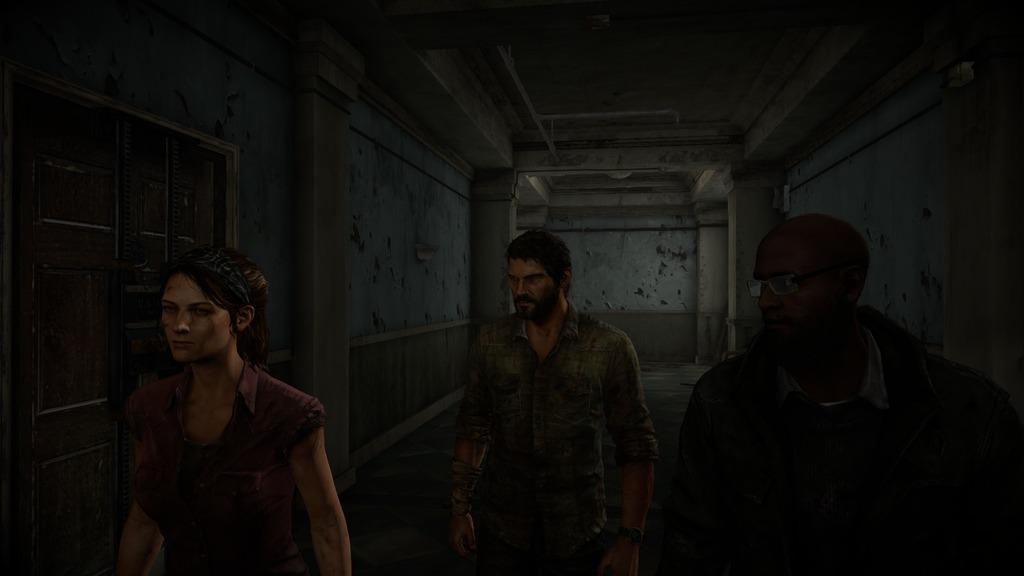How many people are in the image? There are three persons in the image. What type of image is it? The image is animated. What can be seen in the background of the image? There is a door and a wall in the background of the image. What color is the crayon being used by the person in the image? There is no crayon present in the image. What is the title of the animated image? The provided facts do not mention a title for the image. 